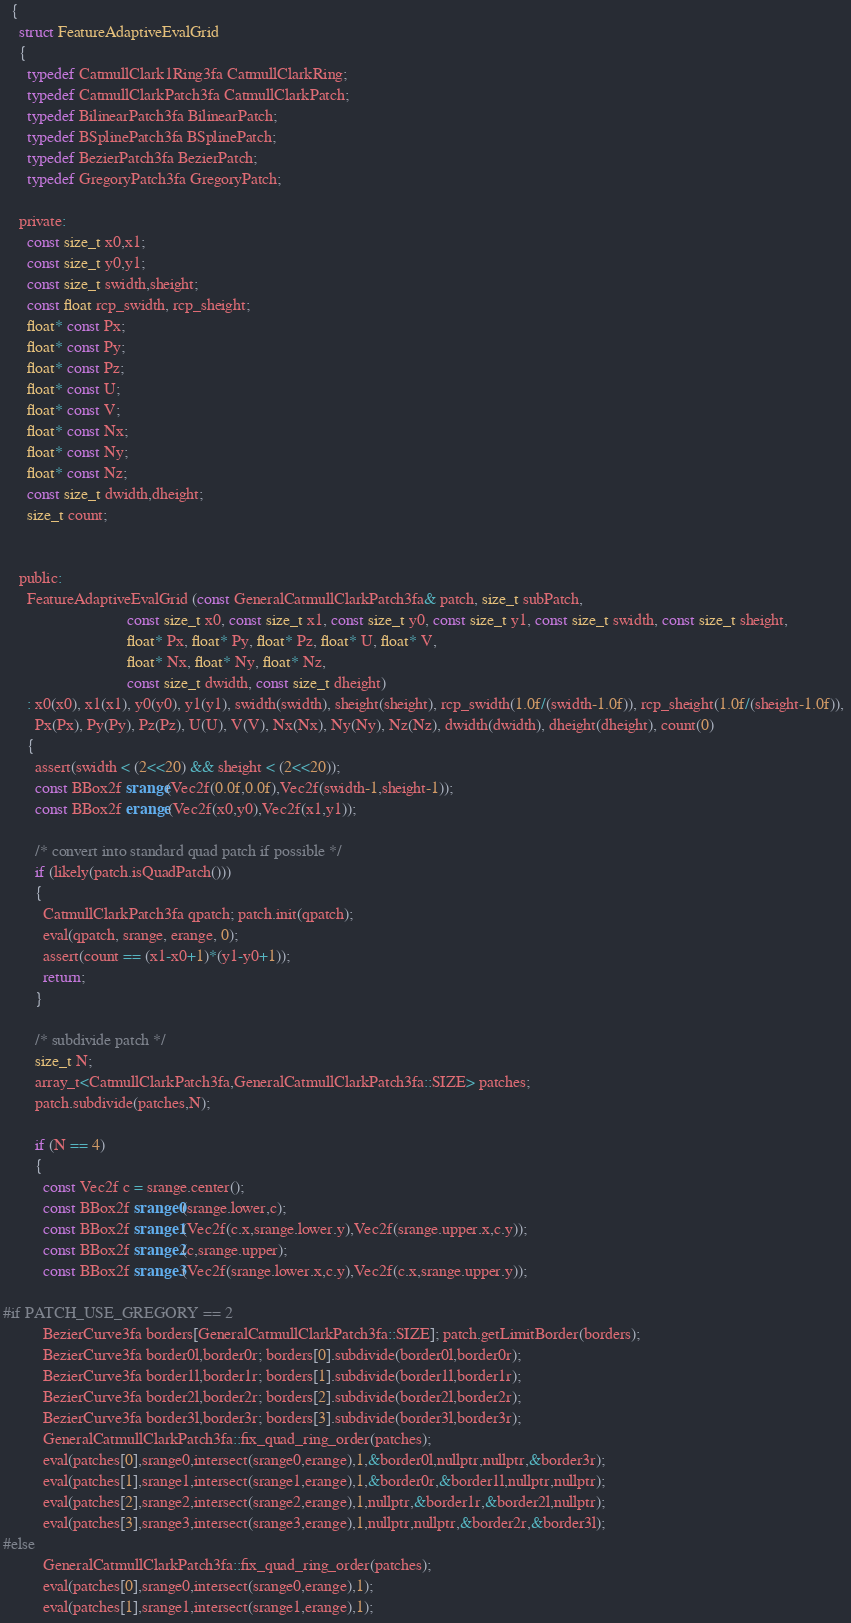<code> <loc_0><loc_0><loc_500><loc_500><_C_>  {
    struct FeatureAdaptiveEvalGrid
    {
      typedef CatmullClark1Ring3fa CatmullClarkRing;
      typedef CatmullClarkPatch3fa CatmullClarkPatch;
      typedef BilinearPatch3fa BilinearPatch;
      typedef BSplinePatch3fa BSplinePatch;
      typedef BezierPatch3fa BezierPatch;
      typedef GregoryPatch3fa GregoryPatch;

    private:
      const size_t x0,x1;
      const size_t y0,y1;
      const size_t swidth,sheight;
      const float rcp_swidth, rcp_sheight;
      float* const Px;
      float* const Py;
      float* const Pz;
      float* const U;
      float* const V;
      float* const Nx;
      float* const Ny;
      float* const Nz;
      const size_t dwidth,dheight;
      size_t count;
      

    public:      
      FeatureAdaptiveEvalGrid (const GeneralCatmullClarkPatch3fa& patch, size_t subPatch,
                               const size_t x0, const size_t x1, const size_t y0, const size_t y1, const size_t swidth, const size_t sheight, 
                               float* Px, float* Py, float* Pz, float* U, float* V, 
                               float* Nx, float* Ny, float* Nz,
                               const size_t dwidth, const size_t dheight)
      : x0(x0), x1(x1), y0(y0), y1(y1), swidth(swidth), sheight(sheight), rcp_swidth(1.0f/(swidth-1.0f)), rcp_sheight(1.0f/(sheight-1.0f)), 
        Px(Px), Py(Py), Pz(Pz), U(U), V(V), Nx(Nx), Ny(Ny), Nz(Nz), dwidth(dwidth), dheight(dheight), count(0)
      {
        assert(swidth < (2<<20) && sheight < (2<<20));
        const BBox2f srange(Vec2f(0.0f,0.0f),Vec2f(swidth-1,sheight-1));
        const BBox2f erange(Vec2f(x0,y0),Vec2f(x1,y1));
        
        /* convert into standard quad patch if possible */
        if (likely(patch.isQuadPatch())) 
        {
          CatmullClarkPatch3fa qpatch; patch.init(qpatch);
          eval(qpatch, srange, erange, 0);
          assert(count == (x1-x0+1)*(y1-y0+1));
          return;
        }
        
        /* subdivide patch */
        size_t N;
        array_t<CatmullClarkPatch3fa,GeneralCatmullClarkPatch3fa::SIZE> patches; 
        patch.subdivide(patches,N);
        
        if (N == 4)
        {
          const Vec2f c = srange.center();
          const BBox2f srange0(srange.lower,c);
          const BBox2f srange1(Vec2f(c.x,srange.lower.y),Vec2f(srange.upper.x,c.y));
          const BBox2f srange2(c,srange.upper);
          const BBox2f srange3(Vec2f(srange.lower.x,c.y),Vec2f(c.x,srange.upper.y));

#if PATCH_USE_GREGORY == 2
          BezierCurve3fa borders[GeneralCatmullClarkPatch3fa::SIZE]; patch.getLimitBorder(borders);
          BezierCurve3fa border0l,border0r; borders[0].subdivide(border0l,border0r);
          BezierCurve3fa border1l,border1r; borders[1].subdivide(border1l,border1r);
          BezierCurve3fa border2l,border2r; borders[2].subdivide(border2l,border2r);
          BezierCurve3fa border3l,border3r; borders[3].subdivide(border3l,border3r);
          GeneralCatmullClarkPatch3fa::fix_quad_ring_order(patches);
          eval(patches[0],srange0,intersect(srange0,erange),1,&border0l,nullptr,nullptr,&border3r);
          eval(patches[1],srange1,intersect(srange1,erange),1,&border0r,&border1l,nullptr,nullptr);
          eval(patches[2],srange2,intersect(srange2,erange),1,nullptr,&border1r,&border2l,nullptr);
          eval(patches[3],srange3,intersect(srange3,erange),1,nullptr,nullptr,&border2r,&border3l);
#else
          GeneralCatmullClarkPatch3fa::fix_quad_ring_order(patches);
          eval(patches[0],srange0,intersect(srange0,erange),1);
          eval(patches[1],srange1,intersect(srange1,erange),1);</code> 